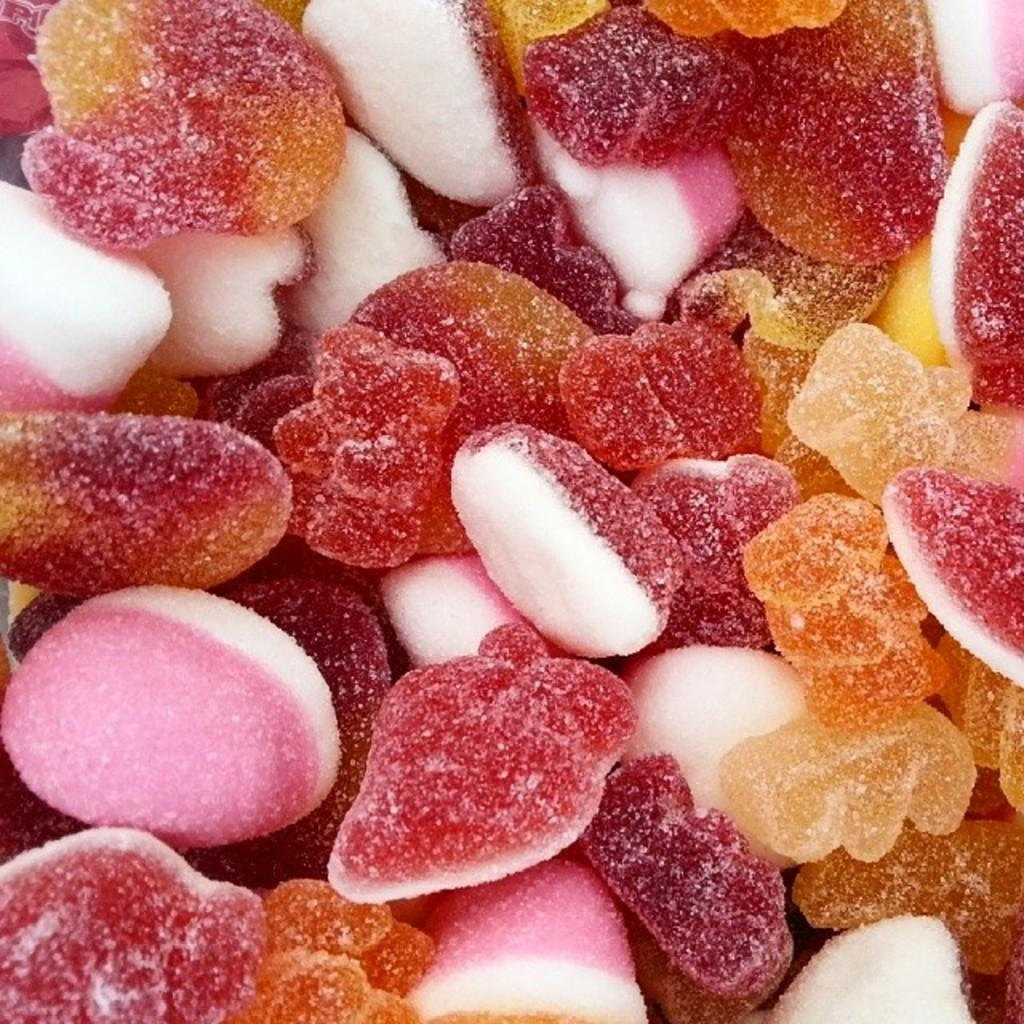What type of food is present in the image? There are candies in the image. Can you see a boat in the image? No, there is no boat present in the image. What is an example of a geometric shape that can be found in the image? There are no geometric shapes mentioned in the provided facts, and the image does not depict any shapes. 